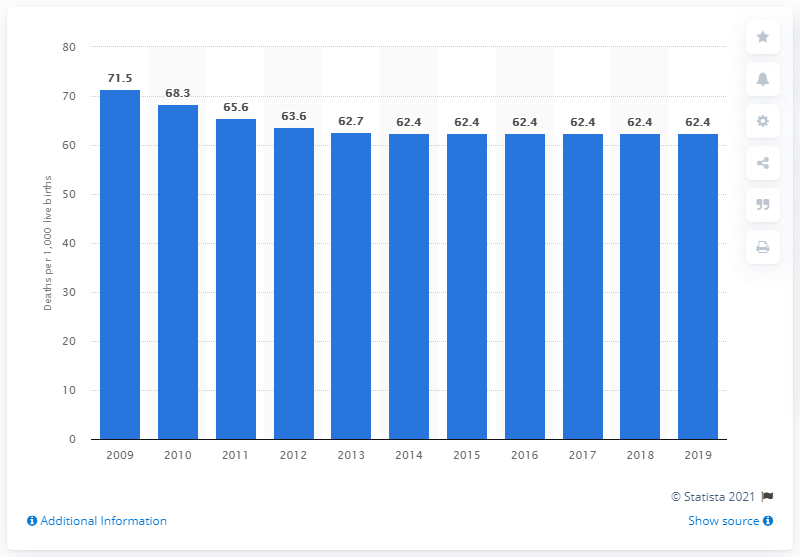Highlight a few significant elements in this photo. In 2019, the infant mortality rate in South Sudan was 62.4," indicating a significant decline from the previous year. 